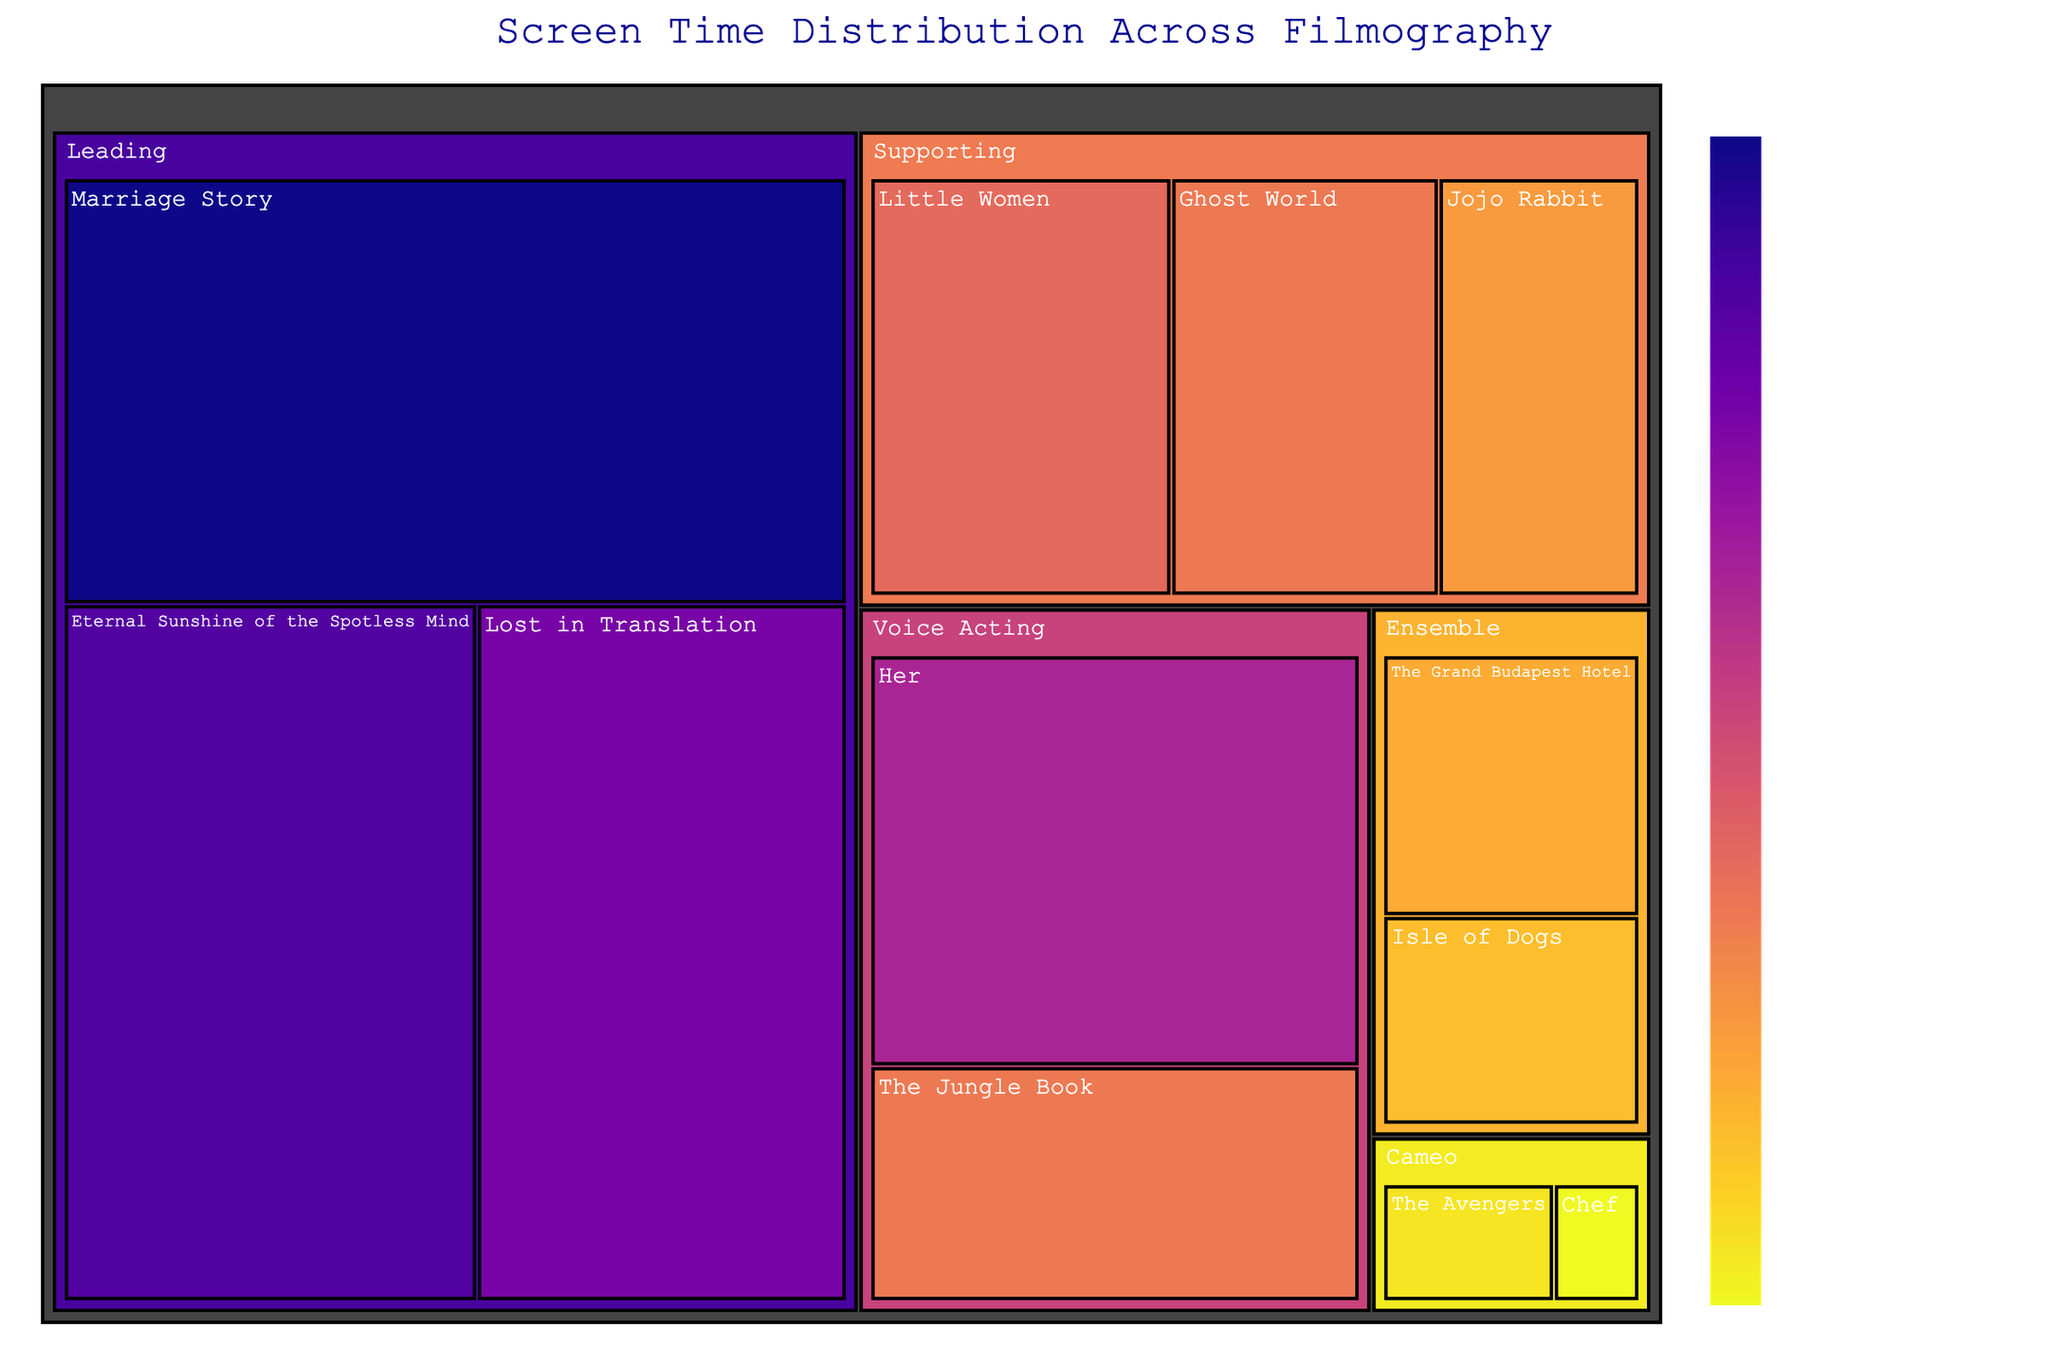What is the title of the Treemap? The Treemap displays a title. The title is typically positioned at the top center of the visualization.
Answer: Screen Time Distribution Across Filmography Which film has the highest screen time and what is the role type? The Treemap tiles will show both the film name and screen time. The tile with the largest screen time indicates the highest screen time. The role type can be identified from the parent category of the tile.
Answer: Marriage Story, Leading How much total screen time does the actress have in 'Voice Acting' roles? Summing up screen times for 'Her' and 'The Jungle Book' will give the total screen time for 'Voice Acting'.
Answer: 70 + 40 = 110 minutes Which role type has the smallest screen time contribution and which films are in this category? Identify the smallest screen tiles and check their parent category. The smallest role type can be seen with its associated films.
Answer: Cameo, Chef and The Avengers Is there more screen time in 'Leading' or 'Supporting' roles? Add the screen times of all films under 'Leading' and 'Supporting' and compare the two sums.
Answer: Leading roles In which supporting role film does the actress have the least screen time? Among the 'Supporting' role tiles, the film with the smallest screen time can be found.
Answer: Jojo Rabbit What is the average screen time for 'Ensemble' roles? Add the screen time of the 'Ensemble' roles and divide by the number of films in this category.
Answer: (25 + 20) / 2 = 22.5 minutes How does the screen time in 'Eternal Sunshine of the Spotless Mind' compare to 'Lost in Translation'? Compare the screen time numbers of these two films directly from the figure.
Answer: Eternal Sunshine of the Spotless Mind > Lost in Translation What is the total screen time across all films? Sum the screen times of all films listed in the Treemap.
Answer: 95 + 85 + 110 + 45 + 30 + 40 + 5 + 10 + 70 + 40 + 25 + 20 = 575 minutes Which film in the 'Leading' category has the shortest screen time? Among the 'Leading' role tiles, find the film with the smallest screen time.
Answer: Lost in Translation 